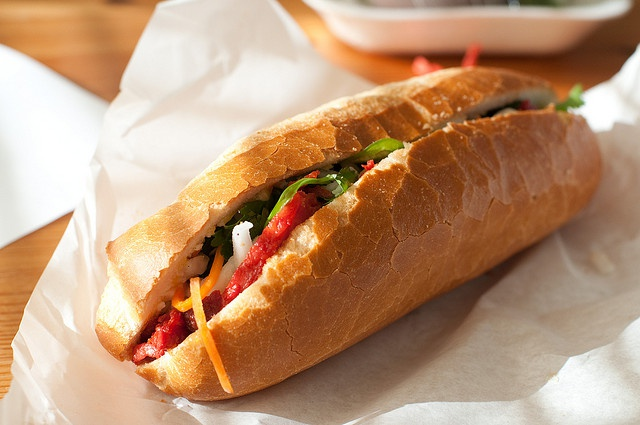Describe the objects in this image and their specific colors. I can see sandwich in tan, brown, maroon, orange, and red tones, hot dog in tan, brown, maroon, orange, and red tones, and carrot in tan, orange, gold, and khaki tones in this image. 